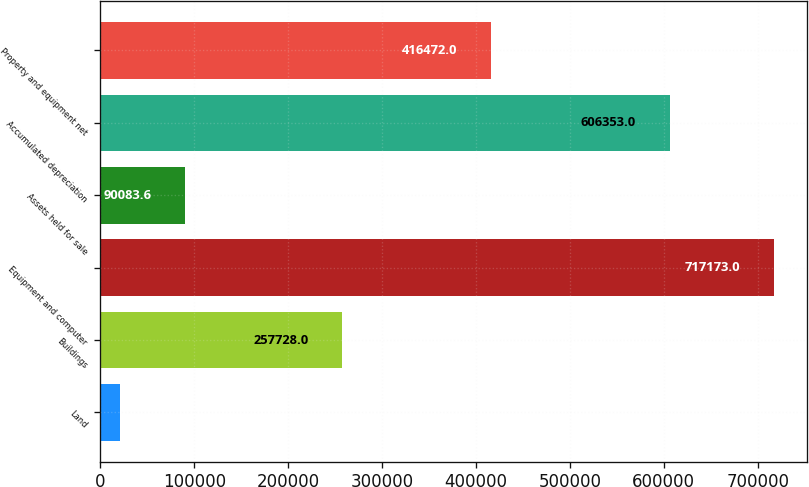Convert chart to OTSL. <chart><loc_0><loc_0><loc_500><loc_500><bar_chart><fcel>Land<fcel>Buildings<fcel>Equipment and computer<fcel>Assets held for sale<fcel>Accumulated depreciation<fcel>Property and equipment net<nl><fcel>20407<fcel>257728<fcel>717173<fcel>90083.6<fcel>606353<fcel>416472<nl></chart> 